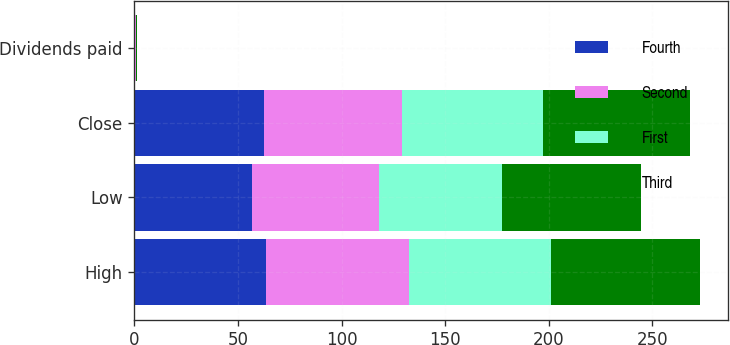Convert chart to OTSL. <chart><loc_0><loc_0><loc_500><loc_500><stacked_bar_chart><ecel><fcel>High<fcel>Low<fcel>Close<fcel>Dividends paid<nl><fcel>Fourth<fcel>63.45<fcel>56.53<fcel>62.78<fcel>0.34<nl><fcel>Second<fcel>69.03<fcel>61.61<fcel>66.54<fcel>0.34<nl><fcel>First<fcel>68.5<fcel>59.13<fcel>67.96<fcel>0.34<nl><fcel>Third<fcel>71.76<fcel>67.27<fcel>70.62<fcel>0.34<nl></chart> 